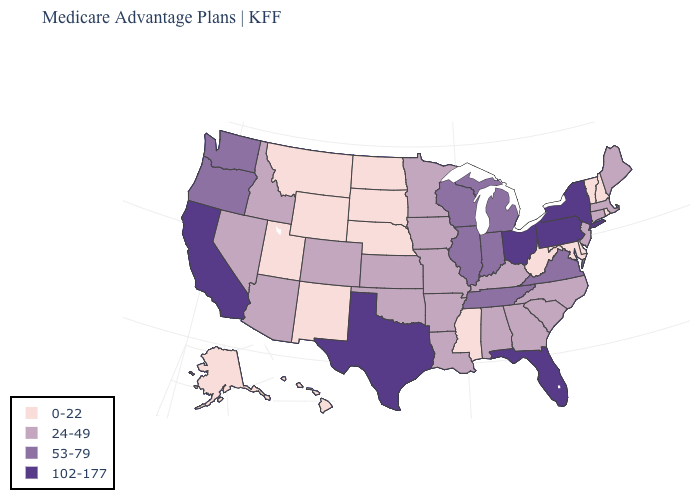Among the states that border Kansas , does Colorado have the highest value?
Concise answer only. Yes. What is the value of Mississippi?
Give a very brief answer. 0-22. Name the states that have a value in the range 0-22?
Give a very brief answer. Alaska, Delaware, Hawaii, Maryland, Mississippi, Montana, North Dakota, Nebraska, New Hampshire, New Mexico, Rhode Island, South Dakota, Utah, Vermont, West Virginia, Wyoming. Does Florida have the highest value in the South?
Short answer required. Yes. Name the states that have a value in the range 0-22?
Write a very short answer. Alaska, Delaware, Hawaii, Maryland, Mississippi, Montana, North Dakota, Nebraska, New Hampshire, New Mexico, Rhode Island, South Dakota, Utah, Vermont, West Virginia, Wyoming. Does the map have missing data?
Give a very brief answer. No. What is the value of Wisconsin?
Quick response, please. 53-79. Which states have the lowest value in the MidWest?
Answer briefly. North Dakota, Nebraska, South Dakota. What is the value of Texas?
Quick response, please. 102-177. What is the value of Maryland?
Quick response, please. 0-22. Does the map have missing data?
Keep it brief. No. What is the value of Arizona?
Answer briefly. 24-49. Name the states that have a value in the range 102-177?
Write a very short answer. California, Florida, New York, Ohio, Pennsylvania, Texas. What is the lowest value in the South?
Be succinct. 0-22. What is the lowest value in the West?
Answer briefly. 0-22. 